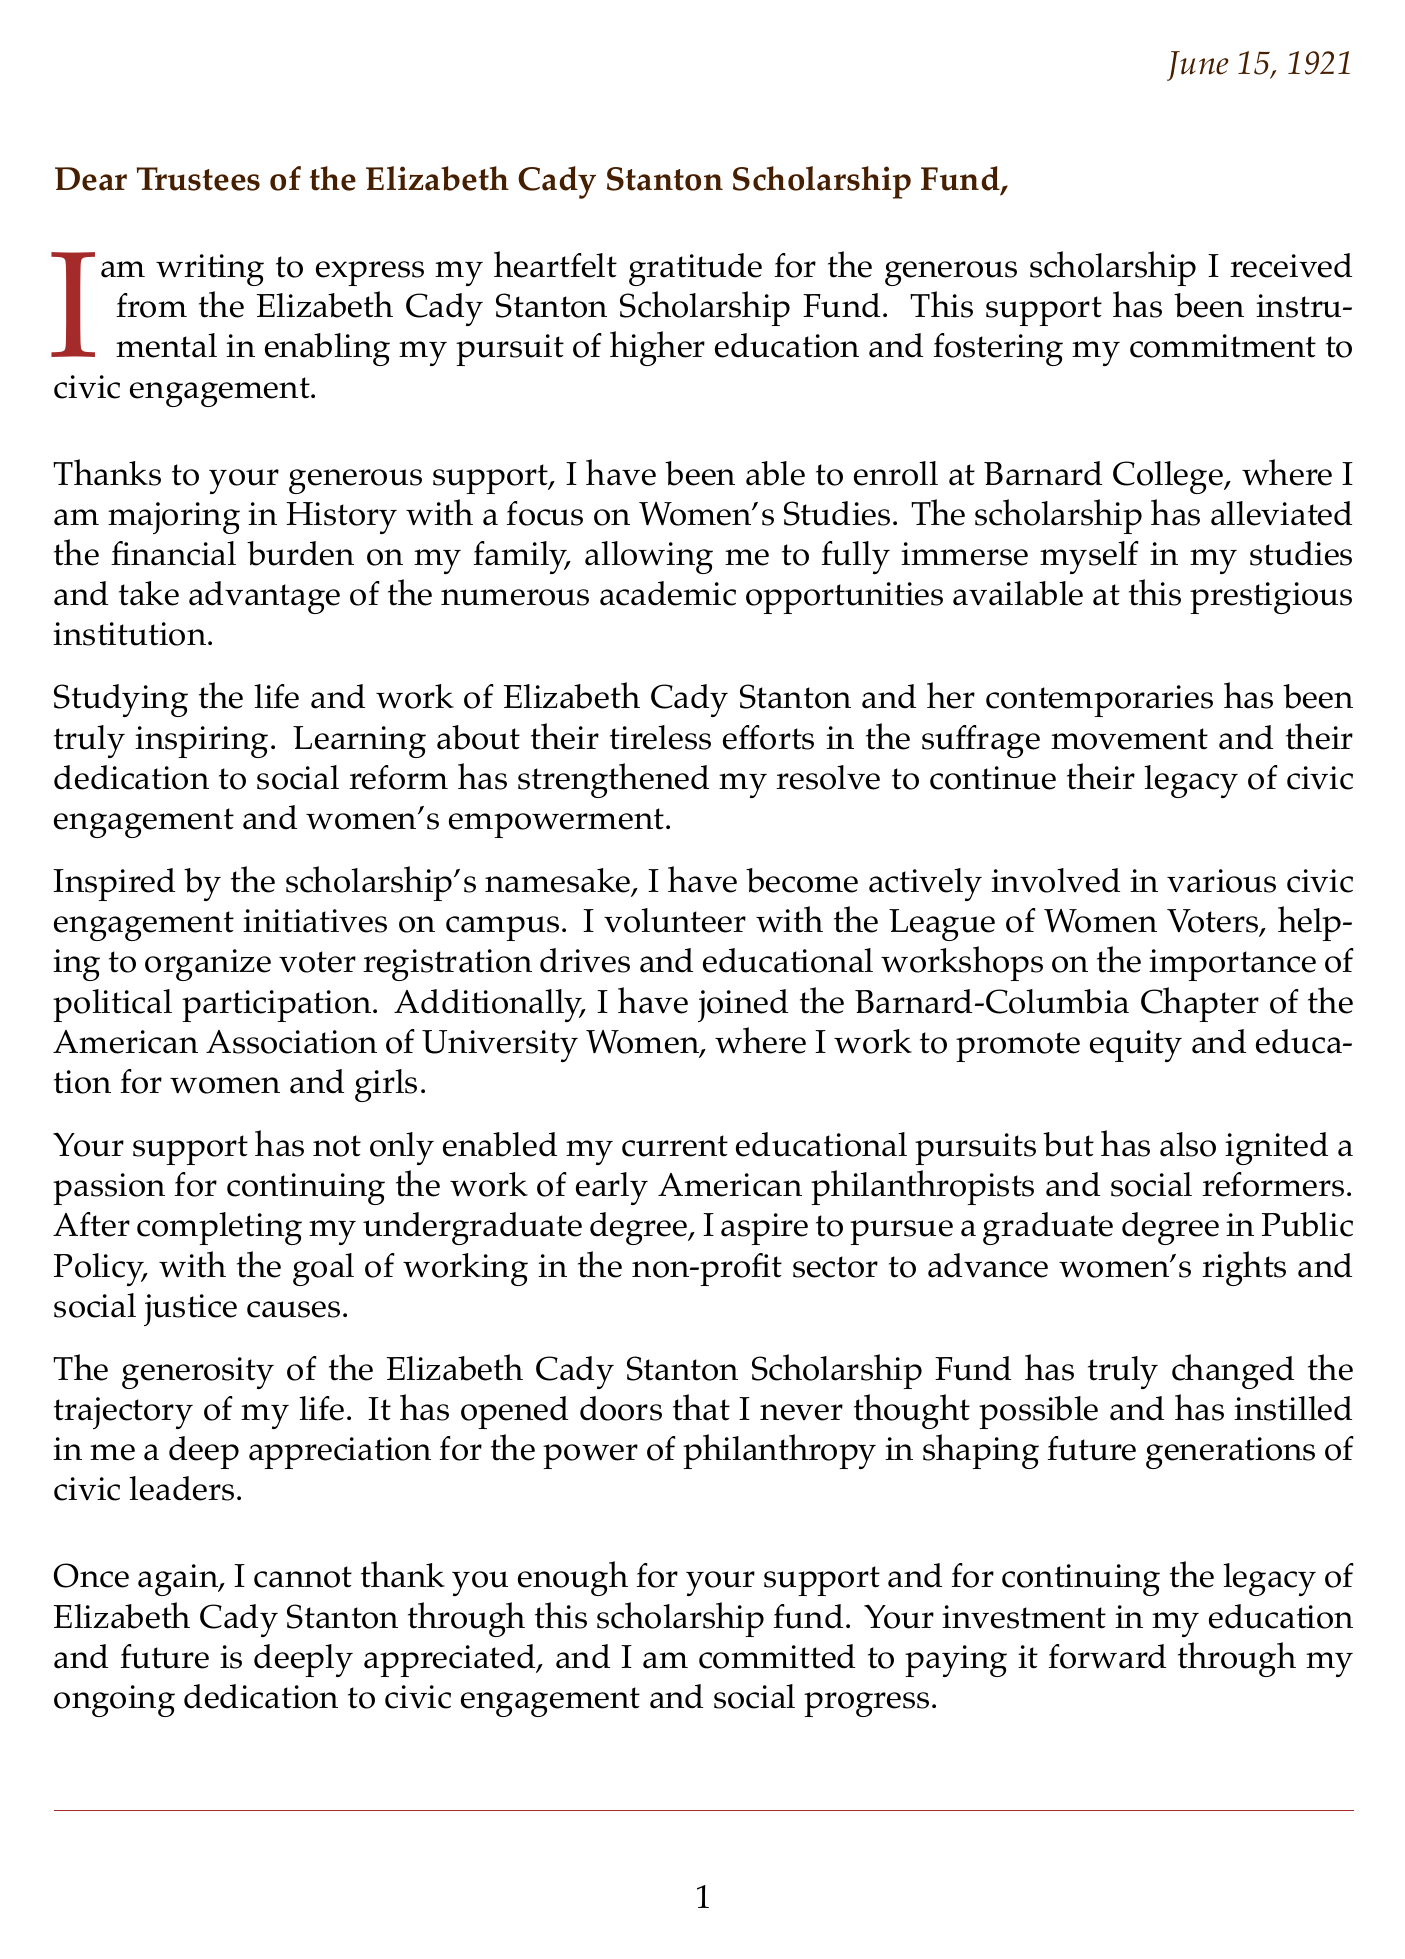What is the name of the scholarship fund? The recipient mentions the scholarship fund by name in the opening of the letter.
Answer: Elizabeth Cady Stanton Scholarship Fund Who is the recipient of the scholarship? The signature at the end of the letter indicates who wrote it.
Answer: Emily Blackwell What is the major of the recipient? The recipient specifies their field of study in the letter.
Answer: History with a focus on Women's Studies What organization does the recipient volunteer with? The letter discusses the recipient's involvement in civic engagement initiatives on campus.
Answer: League of Women Voters In what year was the scholarship fund established? The contextual information provided indicates the founding year of the scholarship.
Answer: 1902 What future degree does the recipient aspire to pursue? The body of the letter describes the recipient's educational and career aspirations.
Answer: Graduate degree in Public Policy Who founded the scholarship fund? The contextual details list the founders of the scholarship fund.
Answer: Carrie Chapman Catt and Anna Howard Shaw What commitment does the recipient express at the end of the letter? The closing remarks of the letter convey the recipient's intention regarding civic engagement.
Answer: Paying it forward through ongoing dedication to civic engagement and social progress 